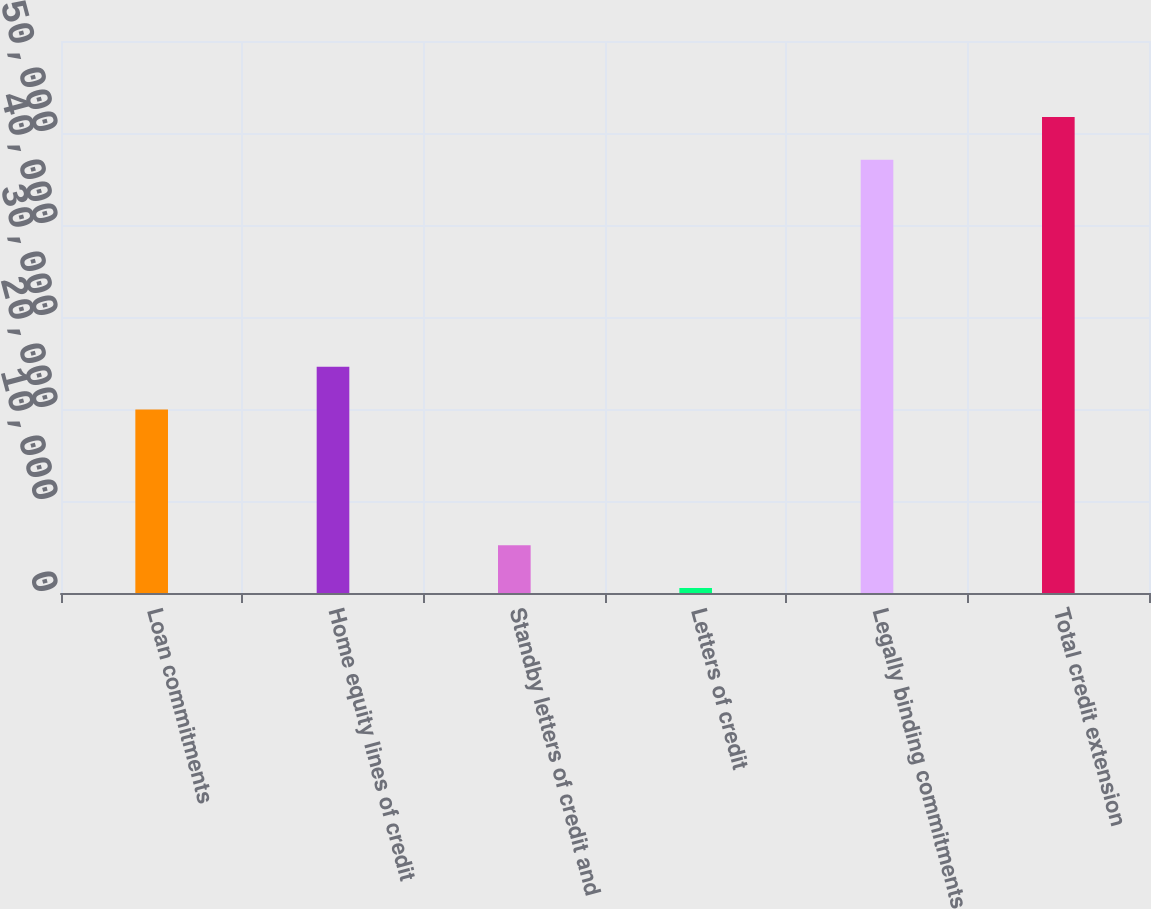Convert chart to OTSL. <chart><loc_0><loc_0><loc_500><loc_500><bar_chart><fcel>Loan commitments<fcel>Home equity lines of credit<fcel>Standby letters of credit and<fcel>Letters of credit<fcel>Legally binding commitments<fcel>Total credit extension<nl><fcel>19942<fcel>24596.9<fcel>5200.9<fcel>546<fcel>47095<fcel>51749.9<nl></chart> 